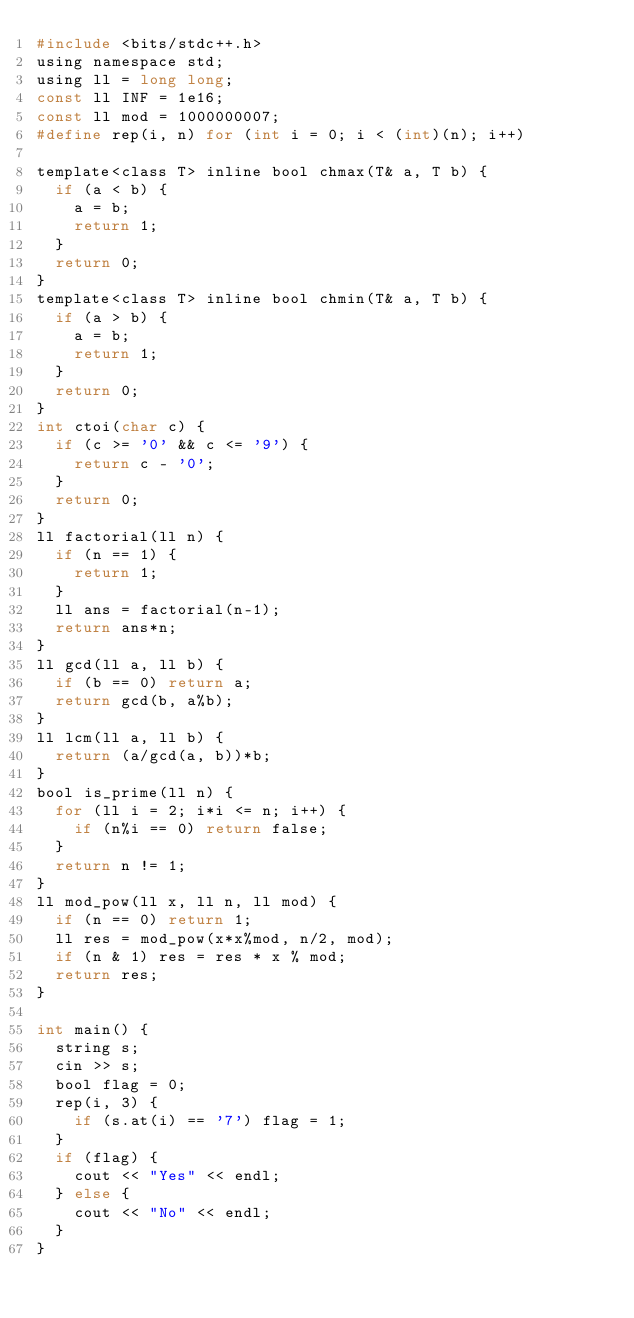<code> <loc_0><loc_0><loc_500><loc_500><_C_>#include <bits/stdc++.h>
using namespace std;
using ll = long long;
const ll INF = 1e16;
const ll mod = 1000000007;
#define rep(i, n) for (int i = 0; i < (int)(n); i++)

template<class T> inline bool chmax(T& a, T b) {
  if (a < b) {
    a = b;
    return 1;
  }
  return 0;
}
template<class T> inline bool chmin(T& a, T b) {
  if (a > b) {
    a = b;
    return 1;
  }
  return 0;
}
int ctoi(char c) {
  if (c >= '0' && c <= '9') {
    return c - '0';
  }
  return 0;
}
ll factorial(ll n) {
  if (n == 1) {
    return 1;
  }
  ll ans = factorial(n-1);
  return ans*n;
}
ll gcd(ll a, ll b) {
  if (b == 0) return a;
  return gcd(b, a%b);
}
ll lcm(ll a, ll b) {
  return (a/gcd(a, b))*b;
}
bool is_prime(ll n) {
  for (ll i = 2; i*i <= n; i++) {
    if (n%i == 0) return false;
  }
  return n != 1;
}
ll mod_pow(ll x, ll n, ll mod) {
  if (n == 0) return 1;
  ll res = mod_pow(x*x%mod, n/2, mod);
  if (n & 1) res = res * x % mod;
  return res;
}

int main() {
  string s;
  cin >> s;
  bool flag = 0;
  rep(i, 3) {
    if (s.at(i) == '7') flag = 1;
  }
  if (flag) {
    cout << "Yes" << endl;
  } else {
    cout << "No" << endl;
  }
}</code> 